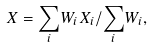Convert formula to latex. <formula><loc_0><loc_0><loc_500><loc_500>X = { \sum _ { i } } W _ { i } X _ { i } / { \sum _ { i } } W _ { i } ,</formula> 